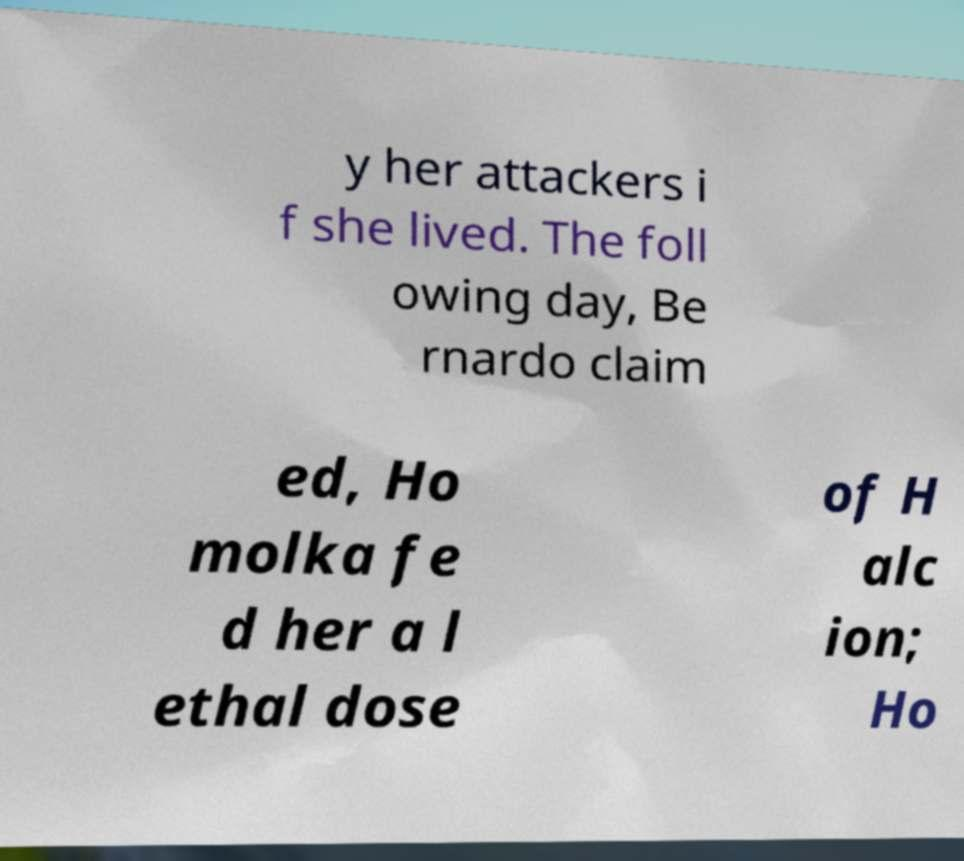Could you assist in decoding the text presented in this image and type it out clearly? y her attackers i f she lived. The foll owing day, Be rnardo claim ed, Ho molka fe d her a l ethal dose of H alc ion; Ho 